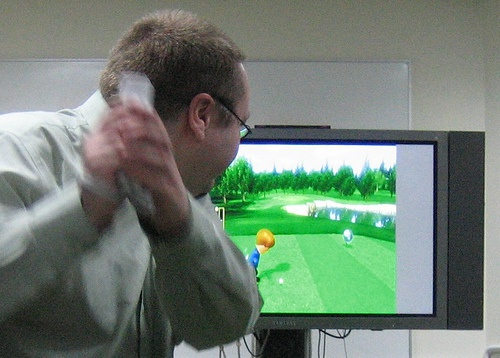Describe the objects in this image and their specific colors. I can see people in gray, black, darkgray, and lightgray tones, tv in gray, darkgray, white, and lightgreen tones, and remote in gray, darkgray, and black tones in this image. 